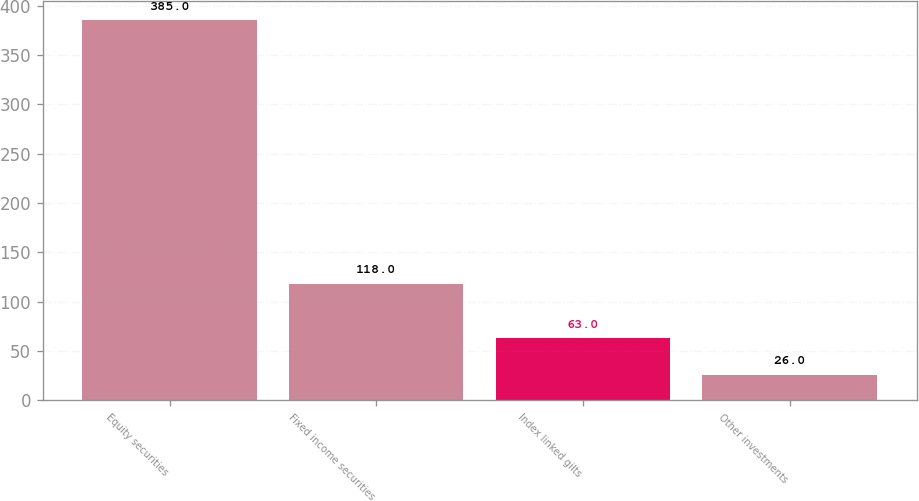Convert chart to OTSL. <chart><loc_0><loc_0><loc_500><loc_500><bar_chart><fcel>Equity securities<fcel>Fixed income securities<fcel>Index linked gilts<fcel>Other investments<nl><fcel>385<fcel>118<fcel>63<fcel>26<nl></chart> 